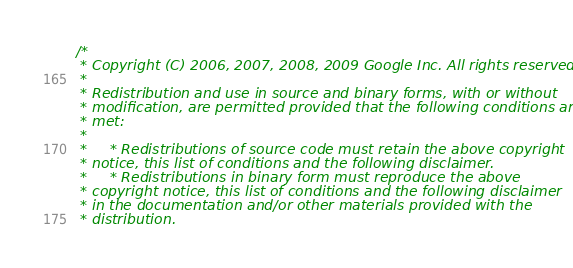<code> <loc_0><loc_0><loc_500><loc_500><_C++_>/*
 * Copyright (C) 2006, 2007, 2008, 2009 Google Inc. All rights reserved.
 *
 * Redistribution and use in source and binary forms, with or without
 * modification, are permitted provided that the following conditions are
 * met:
 *
 *     * Redistributions of source code must retain the above copyright
 * notice, this list of conditions and the following disclaimer.
 *     * Redistributions in binary form must reproduce the above
 * copyright notice, this list of conditions and the following disclaimer
 * in the documentation and/or other materials provided with the
 * distribution.</code> 